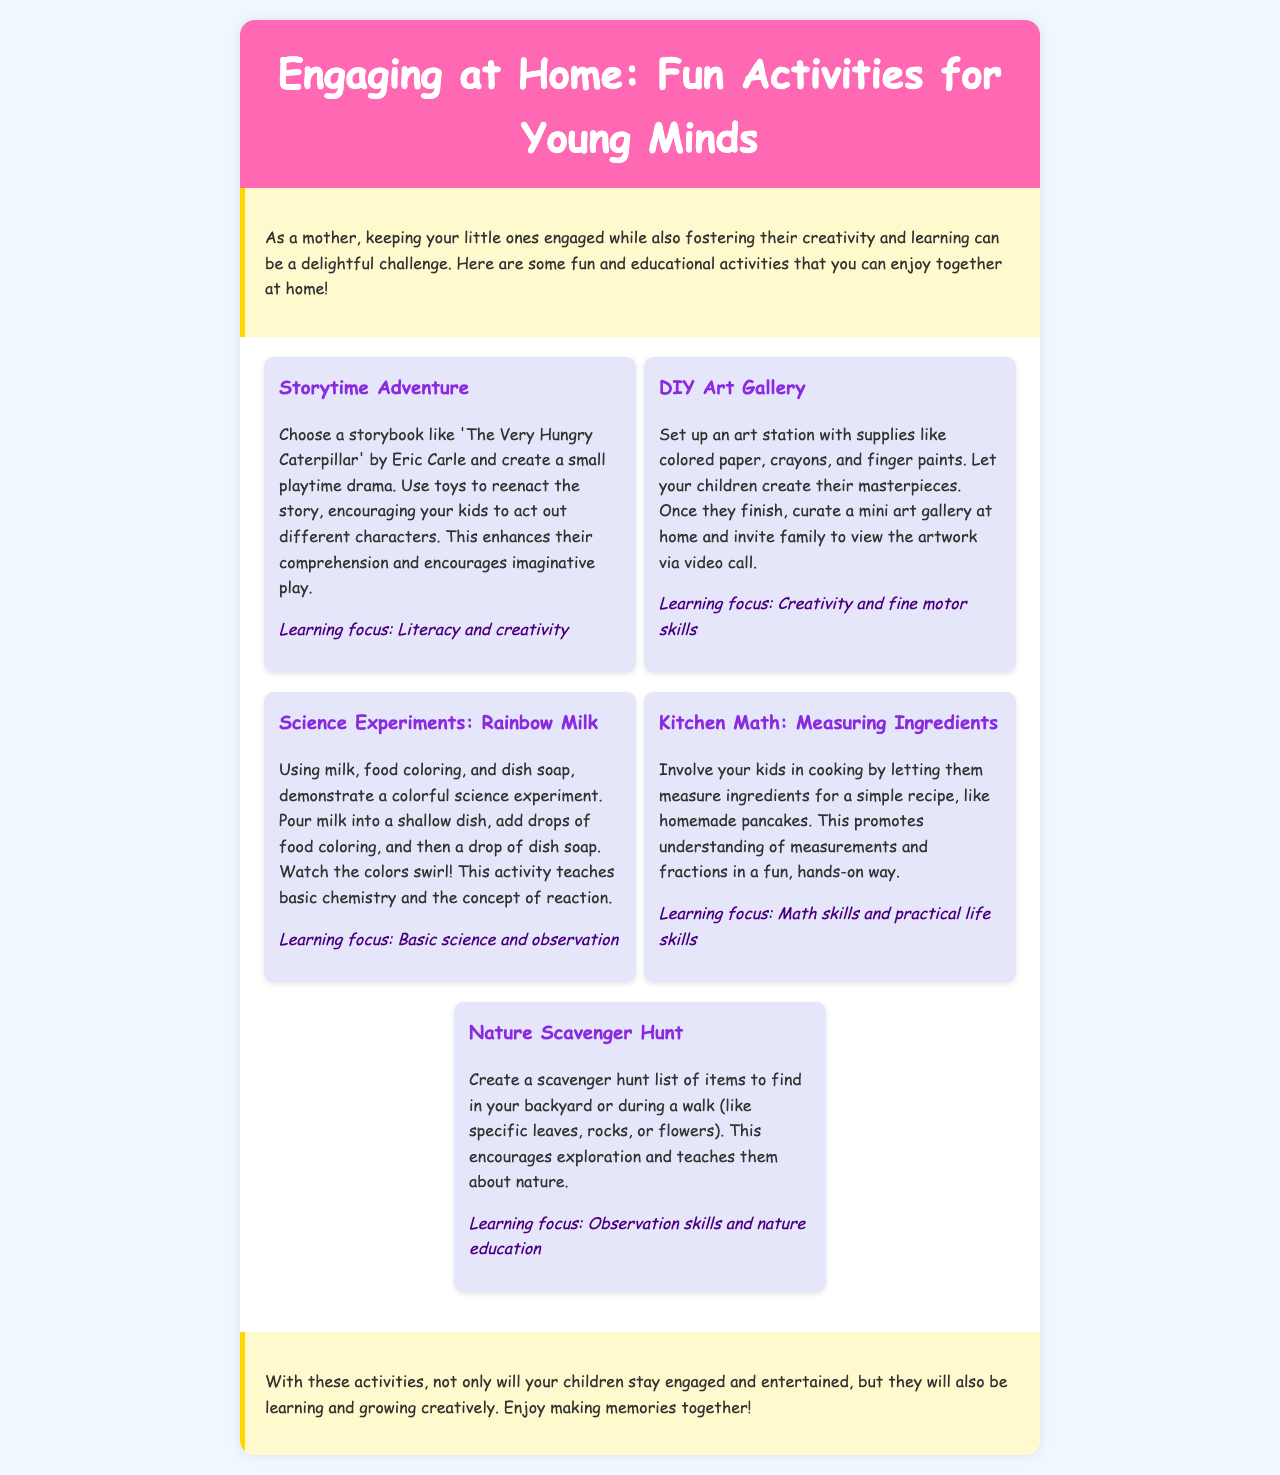What is the title of the newsletter? The title is prominently displayed at the top of the document.
Answer: Engaging at Home: Fun Activities for Young Minds How many activities are listed in the document? The total number of activities can be counted in the activities section of the document.
Answer: Five What is the focus of the "Storytime Adventure" activity? The focus is stated right below the description of the activity.
Answer: Literacy and creativity Which activity involves using food coloring? The activity description specifies the use of food coloring in its experiment.
Answer: Science Experiments: Rainbow Milk What learning focus is associated with "Kitchen Math: Measuring Ingredients"? The learning focus is mentioned at the end of the activity description.
Answer: Math skills and practical life skills What is suggested for the "DIY Art Gallery" activity? The suggestion for the activity can be found within its description text.
Answer: Create masterpieces and curate a mini art gallery What educational value does the "Nature Scavenger Hunt" provide? The document states the educational value below the description of the activity.
Answer: Observation skills and nature education How does the newsletter suggest participating families could view the art gallery? The document specifies the method for viewing the gallery in the description.
Answer: Via video call Which color is used for the header background? The document clearly describes the color used in the header section.
Answer: Pink 